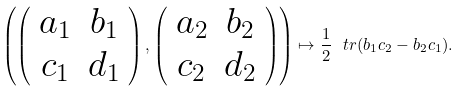<formula> <loc_0><loc_0><loc_500><loc_500>\left ( \left ( \begin{array} { c c } a _ { 1 } & b _ { 1 } \\ c _ { 1 } & d _ { 1 } \end{array} \right ) , \left ( \begin{array} { c c } a _ { 2 } & b _ { 2 } \\ c _ { 2 } & d _ { 2 } \end{array} \right ) \right ) \mapsto \frac { 1 } { 2 } \ t r ( b _ { 1 } c _ { 2 } - b _ { 2 } c _ { 1 } ) .</formula> 